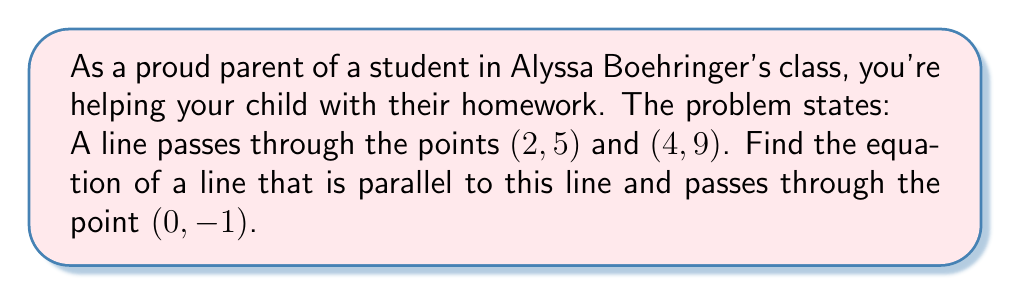Could you help me with this problem? Let's approach this step-by-step:

1) First, we need to find the slope of the given line. We can use the slope formula:

   $m = \frac{y_2 - y_1}{x_2 - x_1} = \frac{9 - 5}{4 - 2} = \frac{4}{2} = 2$

2) The slope of the given line is 2. Since parallel lines have the same slope, our new line will also have a slope of 2.

3) Now we know the slope $(m)$ and a point $(x_1, y_1)$ on our new line: $(0, -1)$. We can use the point-slope form of a line:

   $y - y_1 = m(x - x_1)$

4) Substituting our values:

   $y - (-1) = 2(x - 0)$

5) Simplify:

   $y + 1 = 2x$

6) Rearrange to slope-intercept form $(y = mx + b)$:

   $y = 2x - 1$

This is the equation of our parallel line.
Answer: $y = 2x - 1$ 